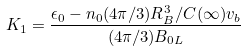Convert formula to latex. <formula><loc_0><loc_0><loc_500><loc_500>K _ { 1 } = \frac { { \epsilon } _ { 0 } - n _ { 0 } ( 4 { \pi } / 3 ) R _ { B } ^ { 3 } / C ( { \infty } ) v _ { b } } { ( 4 { \pi } / 3 ) B _ { 0 L } }</formula> 